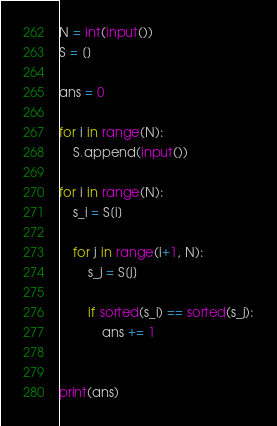<code> <loc_0><loc_0><loc_500><loc_500><_Python_>
N = int(input())
S = []

ans = 0

for i in range(N):
    S.append(input())

for i in range(N):
    s_i = S[i]

    for j in range(i+1, N):
        s_j = S[j]

        if sorted(s_i) == sorted(s_j):
            ans += 1


print(ans)</code> 